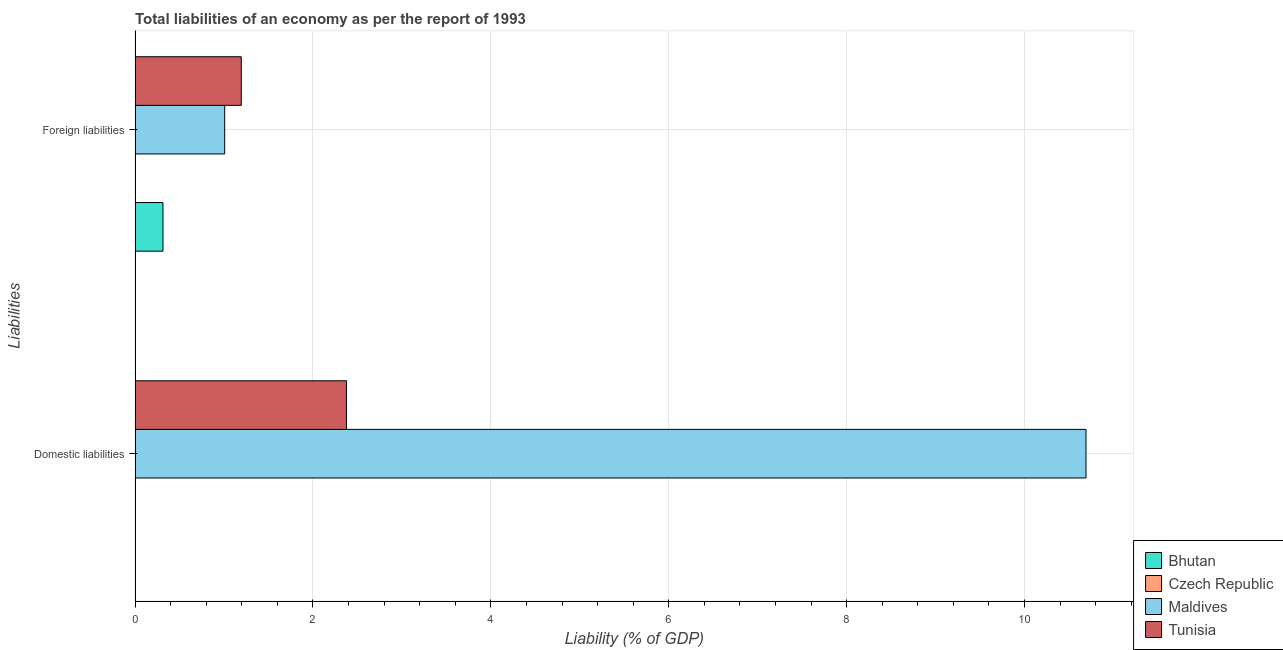How many different coloured bars are there?
Give a very brief answer. 3. How many groups of bars are there?
Offer a terse response. 2. Are the number of bars per tick equal to the number of legend labels?
Provide a short and direct response. No. Are the number of bars on each tick of the Y-axis equal?
Your answer should be compact. No. How many bars are there on the 2nd tick from the top?
Provide a short and direct response. 2. How many bars are there on the 1st tick from the bottom?
Offer a very short reply. 2. What is the label of the 2nd group of bars from the top?
Provide a succinct answer. Domestic liabilities. What is the incurrence of domestic liabilities in Tunisia?
Ensure brevity in your answer.  2.38. Across all countries, what is the maximum incurrence of foreign liabilities?
Make the answer very short. 1.19. In which country was the incurrence of foreign liabilities maximum?
Keep it short and to the point. Tunisia. What is the total incurrence of foreign liabilities in the graph?
Offer a very short reply. 2.52. What is the difference between the incurrence of domestic liabilities in Tunisia and that in Maldives?
Ensure brevity in your answer.  -8.31. What is the average incurrence of domestic liabilities per country?
Your answer should be very brief. 3.27. What is the difference between the incurrence of foreign liabilities and incurrence of domestic liabilities in Maldives?
Your answer should be very brief. -9.68. What is the ratio of the incurrence of foreign liabilities in Bhutan to that in Tunisia?
Give a very brief answer. 0.26. How many countries are there in the graph?
Provide a succinct answer. 4. Are the values on the major ticks of X-axis written in scientific E-notation?
Your answer should be compact. No. How are the legend labels stacked?
Keep it short and to the point. Vertical. What is the title of the graph?
Your response must be concise. Total liabilities of an economy as per the report of 1993. Does "Europe(developing only)" appear as one of the legend labels in the graph?
Your answer should be very brief. No. What is the label or title of the X-axis?
Your answer should be very brief. Liability (% of GDP). What is the label or title of the Y-axis?
Your answer should be compact. Liabilities. What is the Liability (% of GDP) of Bhutan in Domestic liabilities?
Offer a terse response. 0. What is the Liability (% of GDP) in Czech Republic in Domestic liabilities?
Ensure brevity in your answer.  0. What is the Liability (% of GDP) of Maldives in Domestic liabilities?
Your response must be concise. 10.69. What is the Liability (% of GDP) in Tunisia in Domestic liabilities?
Give a very brief answer. 2.38. What is the Liability (% of GDP) in Bhutan in Foreign liabilities?
Your answer should be compact. 0.31. What is the Liability (% of GDP) in Maldives in Foreign liabilities?
Your response must be concise. 1.01. What is the Liability (% of GDP) of Tunisia in Foreign liabilities?
Keep it short and to the point. 1.19. Across all Liabilities, what is the maximum Liability (% of GDP) of Bhutan?
Offer a terse response. 0.31. Across all Liabilities, what is the maximum Liability (% of GDP) of Maldives?
Ensure brevity in your answer.  10.69. Across all Liabilities, what is the maximum Liability (% of GDP) in Tunisia?
Make the answer very short. 2.38. Across all Liabilities, what is the minimum Liability (% of GDP) of Bhutan?
Your response must be concise. 0. Across all Liabilities, what is the minimum Liability (% of GDP) in Maldives?
Your answer should be very brief. 1.01. Across all Liabilities, what is the minimum Liability (% of GDP) of Tunisia?
Offer a very short reply. 1.19. What is the total Liability (% of GDP) of Bhutan in the graph?
Make the answer very short. 0.31. What is the total Liability (% of GDP) in Czech Republic in the graph?
Give a very brief answer. 0. What is the total Liability (% of GDP) in Maldives in the graph?
Your answer should be very brief. 11.7. What is the total Liability (% of GDP) of Tunisia in the graph?
Provide a succinct answer. 3.57. What is the difference between the Liability (% of GDP) in Maldives in Domestic liabilities and that in Foreign liabilities?
Keep it short and to the point. 9.68. What is the difference between the Liability (% of GDP) in Tunisia in Domestic liabilities and that in Foreign liabilities?
Make the answer very short. 1.18. What is the difference between the Liability (% of GDP) in Maldives in Domestic liabilities and the Liability (% of GDP) in Tunisia in Foreign liabilities?
Your answer should be compact. 9.5. What is the average Liability (% of GDP) of Bhutan per Liabilities?
Provide a short and direct response. 0.16. What is the average Liability (% of GDP) of Maldives per Liabilities?
Your response must be concise. 5.85. What is the average Liability (% of GDP) in Tunisia per Liabilities?
Your response must be concise. 1.79. What is the difference between the Liability (% of GDP) in Maldives and Liability (% of GDP) in Tunisia in Domestic liabilities?
Give a very brief answer. 8.31. What is the difference between the Liability (% of GDP) in Bhutan and Liability (% of GDP) in Maldives in Foreign liabilities?
Your response must be concise. -0.69. What is the difference between the Liability (% of GDP) of Bhutan and Liability (% of GDP) of Tunisia in Foreign liabilities?
Keep it short and to the point. -0.88. What is the difference between the Liability (% of GDP) in Maldives and Liability (% of GDP) in Tunisia in Foreign liabilities?
Ensure brevity in your answer.  -0.19. What is the ratio of the Liability (% of GDP) in Maldives in Domestic liabilities to that in Foreign liabilities?
Offer a very short reply. 10.61. What is the ratio of the Liability (% of GDP) of Tunisia in Domestic liabilities to that in Foreign liabilities?
Give a very brief answer. 1.99. What is the difference between the highest and the second highest Liability (% of GDP) in Maldives?
Provide a succinct answer. 9.68. What is the difference between the highest and the second highest Liability (% of GDP) of Tunisia?
Ensure brevity in your answer.  1.18. What is the difference between the highest and the lowest Liability (% of GDP) in Bhutan?
Provide a succinct answer. 0.31. What is the difference between the highest and the lowest Liability (% of GDP) in Maldives?
Your answer should be very brief. 9.68. What is the difference between the highest and the lowest Liability (% of GDP) in Tunisia?
Ensure brevity in your answer.  1.18. 